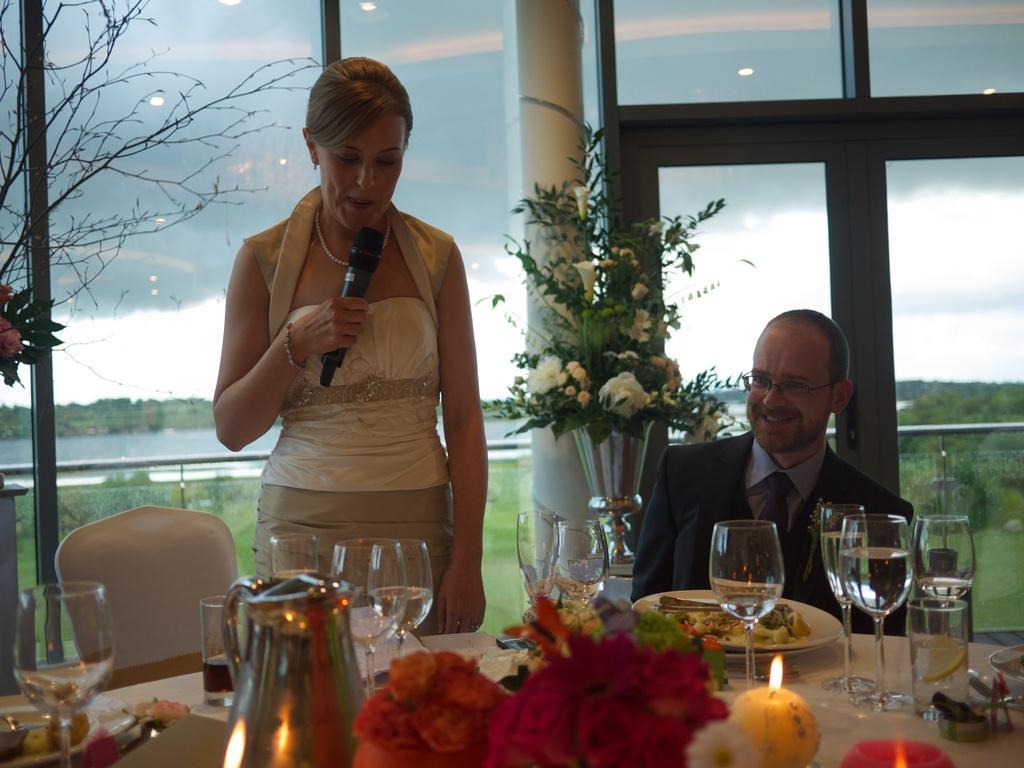Describe this image in one or two sentences. This woman is standing and holds a mic. Beside this woman a man is sitting on a chair. In-front of this people there is a table, on a table there is a candle, flowers, plate, glass and food. Flowers with flower vase. Outside of this glass window there are trees and water. Sky is cloudy. 